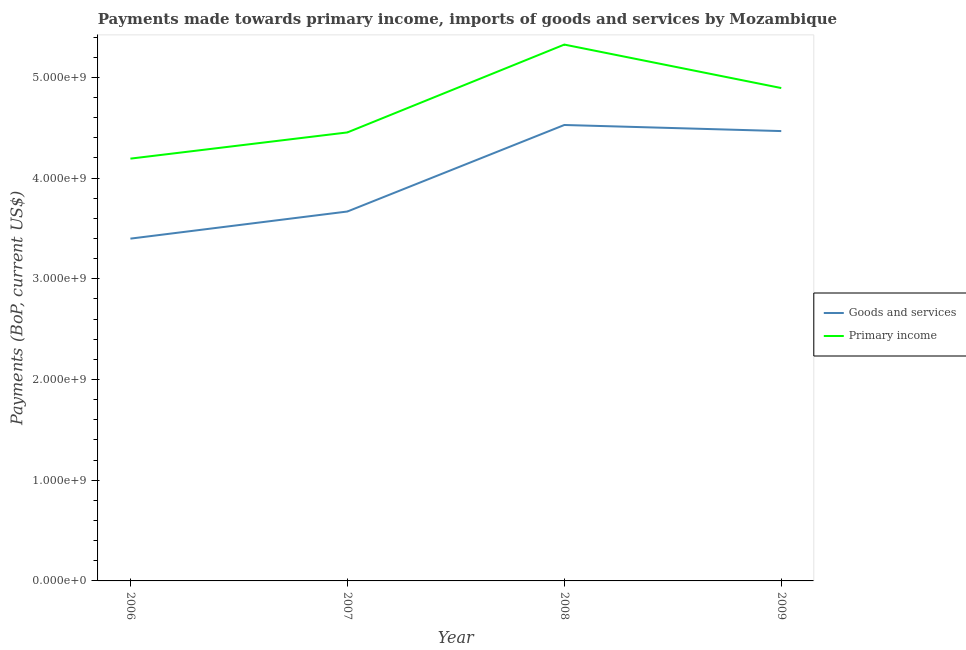How many different coloured lines are there?
Offer a terse response. 2. Is the number of lines equal to the number of legend labels?
Provide a succinct answer. Yes. What is the payments made towards goods and services in 2007?
Make the answer very short. 3.67e+09. Across all years, what is the maximum payments made towards primary income?
Ensure brevity in your answer.  5.33e+09. Across all years, what is the minimum payments made towards primary income?
Offer a very short reply. 4.19e+09. In which year was the payments made towards primary income maximum?
Your answer should be compact. 2008. What is the total payments made towards primary income in the graph?
Keep it short and to the point. 1.89e+1. What is the difference between the payments made towards goods and services in 2008 and that in 2009?
Provide a succinct answer. 6.04e+07. What is the difference between the payments made towards goods and services in 2006 and the payments made towards primary income in 2008?
Make the answer very short. -1.93e+09. What is the average payments made towards goods and services per year?
Your answer should be very brief. 4.01e+09. In the year 2006, what is the difference between the payments made towards goods and services and payments made towards primary income?
Give a very brief answer. -7.94e+08. In how many years, is the payments made towards goods and services greater than 3200000000 US$?
Offer a terse response. 4. What is the ratio of the payments made towards primary income in 2006 to that in 2007?
Ensure brevity in your answer.  0.94. Is the payments made towards primary income in 2008 less than that in 2009?
Offer a terse response. No. What is the difference between the highest and the second highest payments made towards goods and services?
Ensure brevity in your answer.  6.04e+07. What is the difference between the highest and the lowest payments made towards goods and services?
Ensure brevity in your answer.  1.13e+09. In how many years, is the payments made towards primary income greater than the average payments made towards primary income taken over all years?
Ensure brevity in your answer.  2. Is the payments made towards goods and services strictly greater than the payments made towards primary income over the years?
Your answer should be very brief. No. How many lines are there?
Provide a succinct answer. 2. How many years are there in the graph?
Your answer should be very brief. 4. What is the difference between two consecutive major ticks on the Y-axis?
Keep it short and to the point. 1.00e+09. Are the values on the major ticks of Y-axis written in scientific E-notation?
Offer a very short reply. Yes. Does the graph contain any zero values?
Your answer should be compact. No. What is the title of the graph?
Your response must be concise. Payments made towards primary income, imports of goods and services by Mozambique. Does "Female labourers" appear as one of the legend labels in the graph?
Give a very brief answer. No. What is the label or title of the X-axis?
Provide a succinct answer. Year. What is the label or title of the Y-axis?
Provide a succinct answer. Payments (BoP, current US$). What is the Payments (BoP, current US$) of Goods and services in 2006?
Give a very brief answer. 3.40e+09. What is the Payments (BoP, current US$) of Primary income in 2006?
Your response must be concise. 4.19e+09. What is the Payments (BoP, current US$) of Goods and services in 2007?
Provide a short and direct response. 3.67e+09. What is the Payments (BoP, current US$) in Primary income in 2007?
Make the answer very short. 4.45e+09. What is the Payments (BoP, current US$) in Goods and services in 2008?
Make the answer very short. 4.53e+09. What is the Payments (BoP, current US$) in Primary income in 2008?
Offer a very short reply. 5.33e+09. What is the Payments (BoP, current US$) of Goods and services in 2009?
Offer a terse response. 4.47e+09. What is the Payments (BoP, current US$) of Primary income in 2009?
Ensure brevity in your answer.  4.89e+09. Across all years, what is the maximum Payments (BoP, current US$) in Goods and services?
Your response must be concise. 4.53e+09. Across all years, what is the maximum Payments (BoP, current US$) of Primary income?
Your response must be concise. 5.33e+09. Across all years, what is the minimum Payments (BoP, current US$) of Goods and services?
Your answer should be very brief. 3.40e+09. Across all years, what is the minimum Payments (BoP, current US$) of Primary income?
Keep it short and to the point. 4.19e+09. What is the total Payments (BoP, current US$) in Goods and services in the graph?
Your answer should be compact. 1.61e+1. What is the total Payments (BoP, current US$) in Primary income in the graph?
Provide a succinct answer. 1.89e+1. What is the difference between the Payments (BoP, current US$) of Goods and services in 2006 and that in 2007?
Your answer should be compact. -2.69e+08. What is the difference between the Payments (BoP, current US$) of Primary income in 2006 and that in 2007?
Make the answer very short. -2.60e+08. What is the difference between the Payments (BoP, current US$) in Goods and services in 2006 and that in 2008?
Your response must be concise. -1.13e+09. What is the difference between the Payments (BoP, current US$) in Primary income in 2006 and that in 2008?
Offer a terse response. -1.13e+09. What is the difference between the Payments (BoP, current US$) in Goods and services in 2006 and that in 2009?
Provide a short and direct response. -1.07e+09. What is the difference between the Payments (BoP, current US$) of Primary income in 2006 and that in 2009?
Your response must be concise. -7.01e+08. What is the difference between the Payments (BoP, current US$) of Goods and services in 2007 and that in 2008?
Provide a succinct answer. -8.59e+08. What is the difference between the Payments (BoP, current US$) of Primary income in 2007 and that in 2008?
Provide a succinct answer. -8.72e+08. What is the difference between the Payments (BoP, current US$) in Goods and services in 2007 and that in 2009?
Offer a terse response. -7.99e+08. What is the difference between the Payments (BoP, current US$) in Primary income in 2007 and that in 2009?
Offer a very short reply. -4.41e+08. What is the difference between the Payments (BoP, current US$) in Goods and services in 2008 and that in 2009?
Offer a very short reply. 6.04e+07. What is the difference between the Payments (BoP, current US$) in Primary income in 2008 and that in 2009?
Your answer should be compact. 4.32e+08. What is the difference between the Payments (BoP, current US$) of Goods and services in 2006 and the Payments (BoP, current US$) of Primary income in 2007?
Provide a short and direct response. -1.05e+09. What is the difference between the Payments (BoP, current US$) of Goods and services in 2006 and the Payments (BoP, current US$) of Primary income in 2008?
Keep it short and to the point. -1.93e+09. What is the difference between the Payments (BoP, current US$) in Goods and services in 2006 and the Payments (BoP, current US$) in Primary income in 2009?
Provide a short and direct response. -1.50e+09. What is the difference between the Payments (BoP, current US$) in Goods and services in 2007 and the Payments (BoP, current US$) in Primary income in 2008?
Offer a terse response. -1.66e+09. What is the difference between the Payments (BoP, current US$) of Goods and services in 2007 and the Payments (BoP, current US$) of Primary income in 2009?
Provide a succinct answer. -1.23e+09. What is the difference between the Payments (BoP, current US$) in Goods and services in 2008 and the Payments (BoP, current US$) in Primary income in 2009?
Your answer should be compact. -3.67e+08. What is the average Payments (BoP, current US$) in Goods and services per year?
Ensure brevity in your answer.  4.01e+09. What is the average Payments (BoP, current US$) of Primary income per year?
Give a very brief answer. 4.72e+09. In the year 2006, what is the difference between the Payments (BoP, current US$) in Goods and services and Payments (BoP, current US$) in Primary income?
Ensure brevity in your answer.  -7.94e+08. In the year 2007, what is the difference between the Payments (BoP, current US$) of Goods and services and Payments (BoP, current US$) of Primary income?
Offer a very short reply. -7.85e+08. In the year 2008, what is the difference between the Payments (BoP, current US$) of Goods and services and Payments (BoP, current US$) of Primary income?
Your answer should be very brief. -7.98e+08. In the year 2009, what is the difference between the Payments (BoP, current US$) of Goods and services and Payments (BoP, current US$) of Primary income?
Ensure brevity in your answer.  -4.27e+08. What is the ratio of the Payments (BoP, current US$) of Goods and services in 2006 to that in 2007?
Ensure brevity in your answer.  0.93. What is the ratio of the Payments (BoP, current US$) in Primary income in 2006 to that in 2007?
Make the answer very short. 0.94. What is the ratio of the Payments (BoP, current US$) of Goods and services in 2006 to that in 2008?
Your response must be concise. 0.75. What is the ratio of the Payments (BoP, current US$) in Primary income in 2006 to that in 2008?
Provide a succinct answer. 0.79. What is the ratio of the Payments (BoP, current US$) in Goods and services in 2006 to that in 2009?
Offer a very short reply. 0.76. What is the ratio of the Payments (BoP, current US$) of Primary income in 2006 to that in 2009?
Ensure brevity in your answer.  0.86. What is the ratio of the Payments (BoP, current US$) of Goods and services in 2007 to that in 2008?
Provide a short and direct response. 0.81. What is the ratio of the Payments (BoP, current US$) of Primary income in 2007 to that in 2008?
Provide a short and direct response. 0.84. What is the ratio of the Payments (BoP, current US$) of Goods and services in 2007 to that in 2009?
Provide a succinct answer. 0.82. What is the ratio of the Payments (BoP, current US$) in Primary income in 2007 to that in 2009?
Keep it short and to the point. 0.91. What is the ratio of the Payments (BoP, current US$) of Goods and services in 2008 to that in 2009?
Ensure brevity in your answer.  1.01. What is the ratio of the Payments (BoP, current US$) of Primary income in 2008 to that in 2009?
Offer a very short reply. 1.09. What is the difference between the highest and the second highest Payments (BoP, current US$) of Goods and services?
Give a very brief answer. 6.04e+07. What is the difference between the highest and the second highest Payments (BoP, current US$) of Primary income?
Provide a short and direct response. 4.32e+08. What is the difference between the highest and the lowest Payments (BoP, current US$) of Goods and services?
Offer a very short reply. 1.13e+09. What is the difference between the highest and the lowest Payments (BoP, current US$) in Primary income?
Your response must be concise. 1.13e+09. 